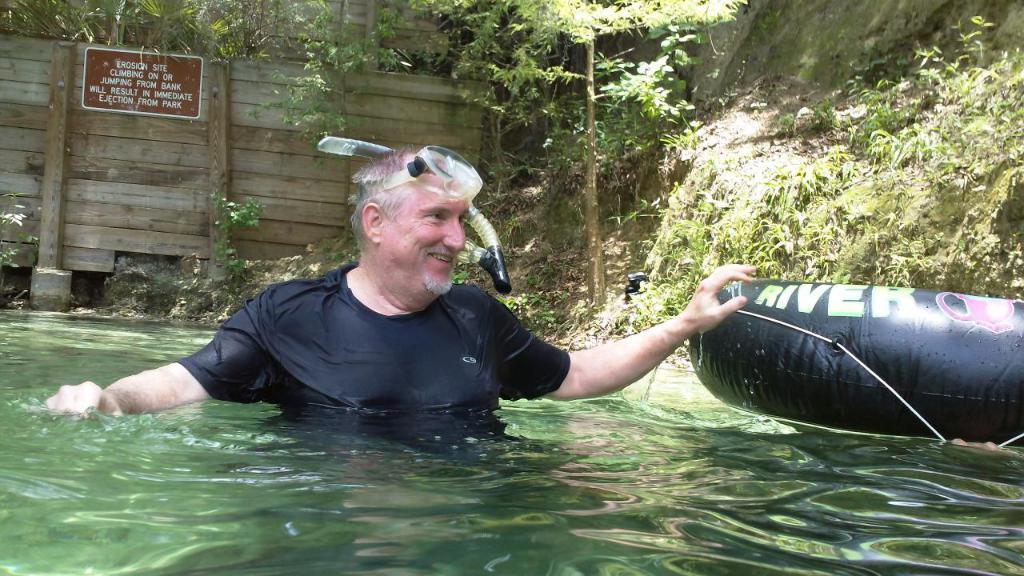In one or two sentences, can you explain what this image depicts? In the foreground of the picture there is a water body, in the water there is a person and an object. In the background there are trees, plants, soil, wall, board and other objects. 